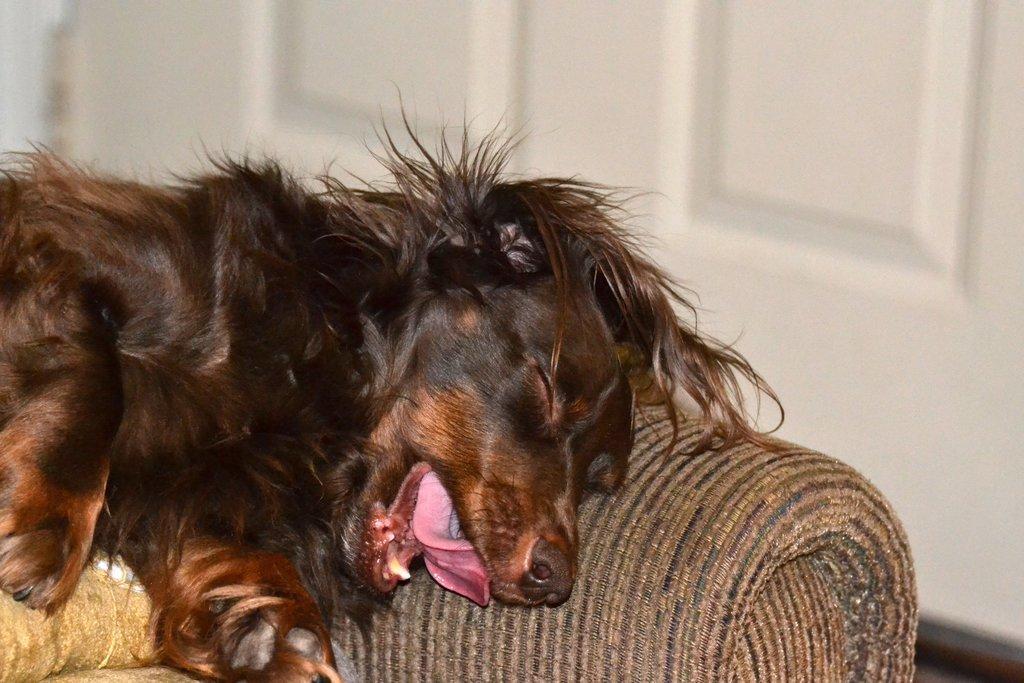Could you give a brief overview of what you see in this image? In this image we can see a dog on the couch and in the background, it looks like the wall. 